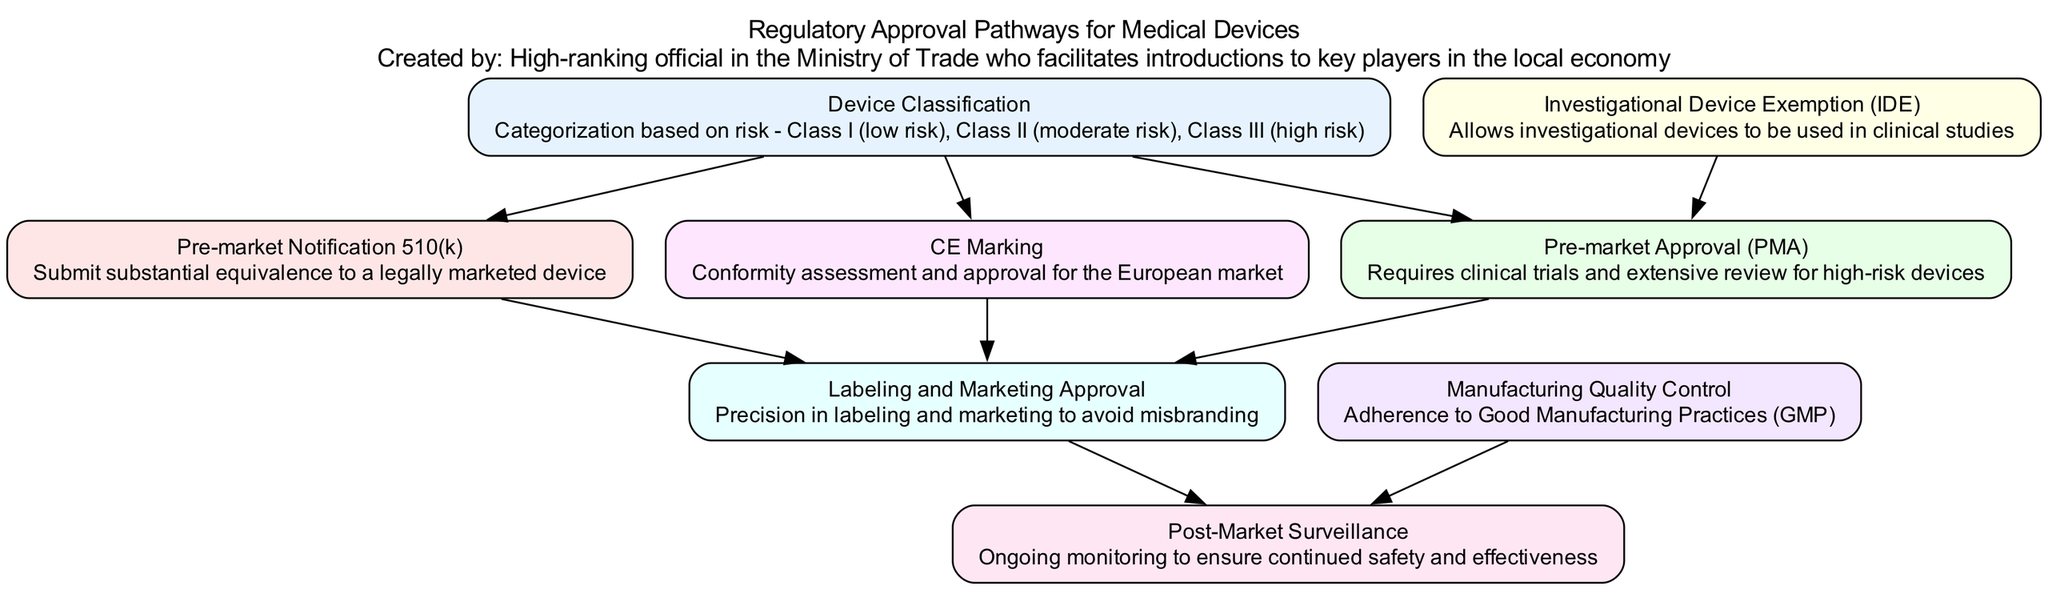What is the first step in the regulatory approval pathway? The first step in the regulatory approval pathway is "Device Classification." This node is positioned at the top of the diagram, indicating it is the starting point.
Answer: Device Classification How many types of pre-market submissions are depicted? There are two types of pre-market submissions shown in the diagram: "Pre-market Notification 510(k)" and "Pre-market Approval (PMA)." These are both directly connected to "Device Classification."
Answer: 2 What follows "Labeling and Marketing Approval" in the pathway? "Post-Market Surveillance" directly follows "Labeling and Marketing Approval," as indicated by the connection from the labeling node to the surveillance node.
Answer: Post-Market Surveillance Which regulatory body is responsible for "CE Marking"? The "European Medicines Agency (EMA)" is the authority responsible for "CE Marking," as noted in the description of that node.
Answer: European Medicines Agency (EMA) What is required for "Pre-market Approval (PMA)"? "Clinical trials and extensive review" are required for "Pre-market Approval (PMA)." This description is directly associated with the PMA node, illustrating the rigorous process involved.
Answer: Clinical trials and extensive review Which node is primarily focused on manufacturing practices? "Manufacturing Quality Control" focuses on manufacturing practices, specifically adherence to Good Manufacturing Practices (GMP). It is a crucial step in ensuring device quality before market approval.
Answer: Manufacturing Quality Control How does "Investigational Device Exemption (IDE)" relate to "Pre-market Approval (PMA)"? The "Investigational Device Exemption (IDE)" allows investigational devices to be used in clinical studies, and it feeds into the "Pre-market Approval (PMA)" process, indicating that IDE is a prerequisite for certain submissions.
Answer: Prerequisite What type of devices does "Device Classification" determine? "Device Classification" determines the categorization of devices based on risk, specifically identifying them as Class I (low risk), Class II (moderate risk), or Class III (high risk).
Answer: Categorization by risk What ongoing process is tied to "Post-Market Surveillance"? The ongoing process tied to "Post-Market Surveillance" is the need for "Ongoing monitoring to ensure continued safety and effectiveness," which is crucial even after the product reaches the market.
Answer: Ongoing monitoring 